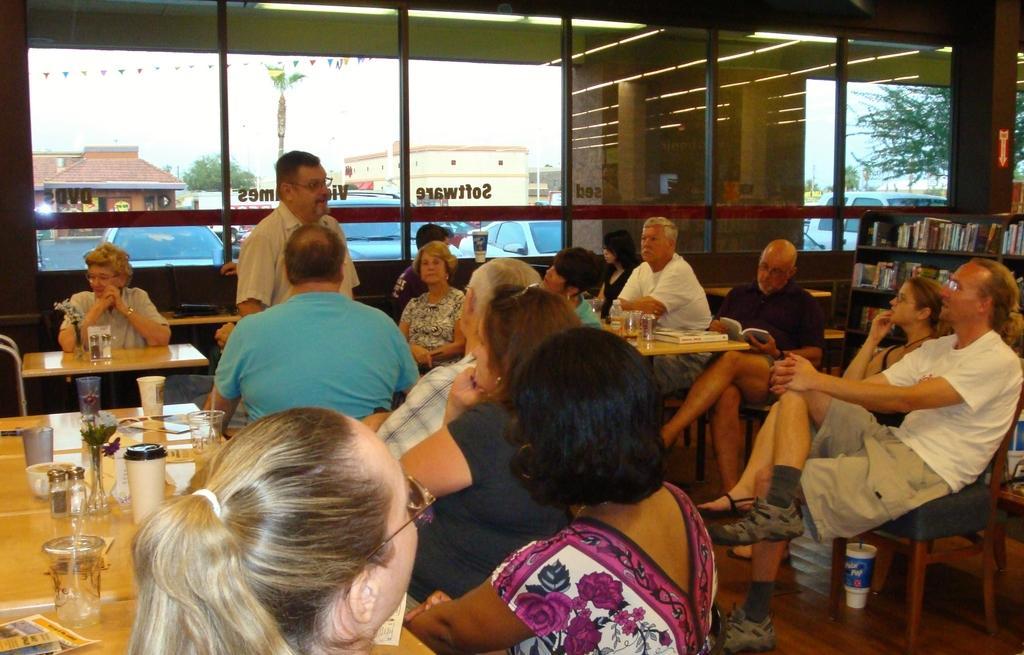In one or two sentences, can you explain what this image depicts? There are many people sitting in the chair in front of the tables. There are men and women in this group. On the table there are cups, glasses and some food items were there. In the background there is a window from which we can observe sky and some trees here. 